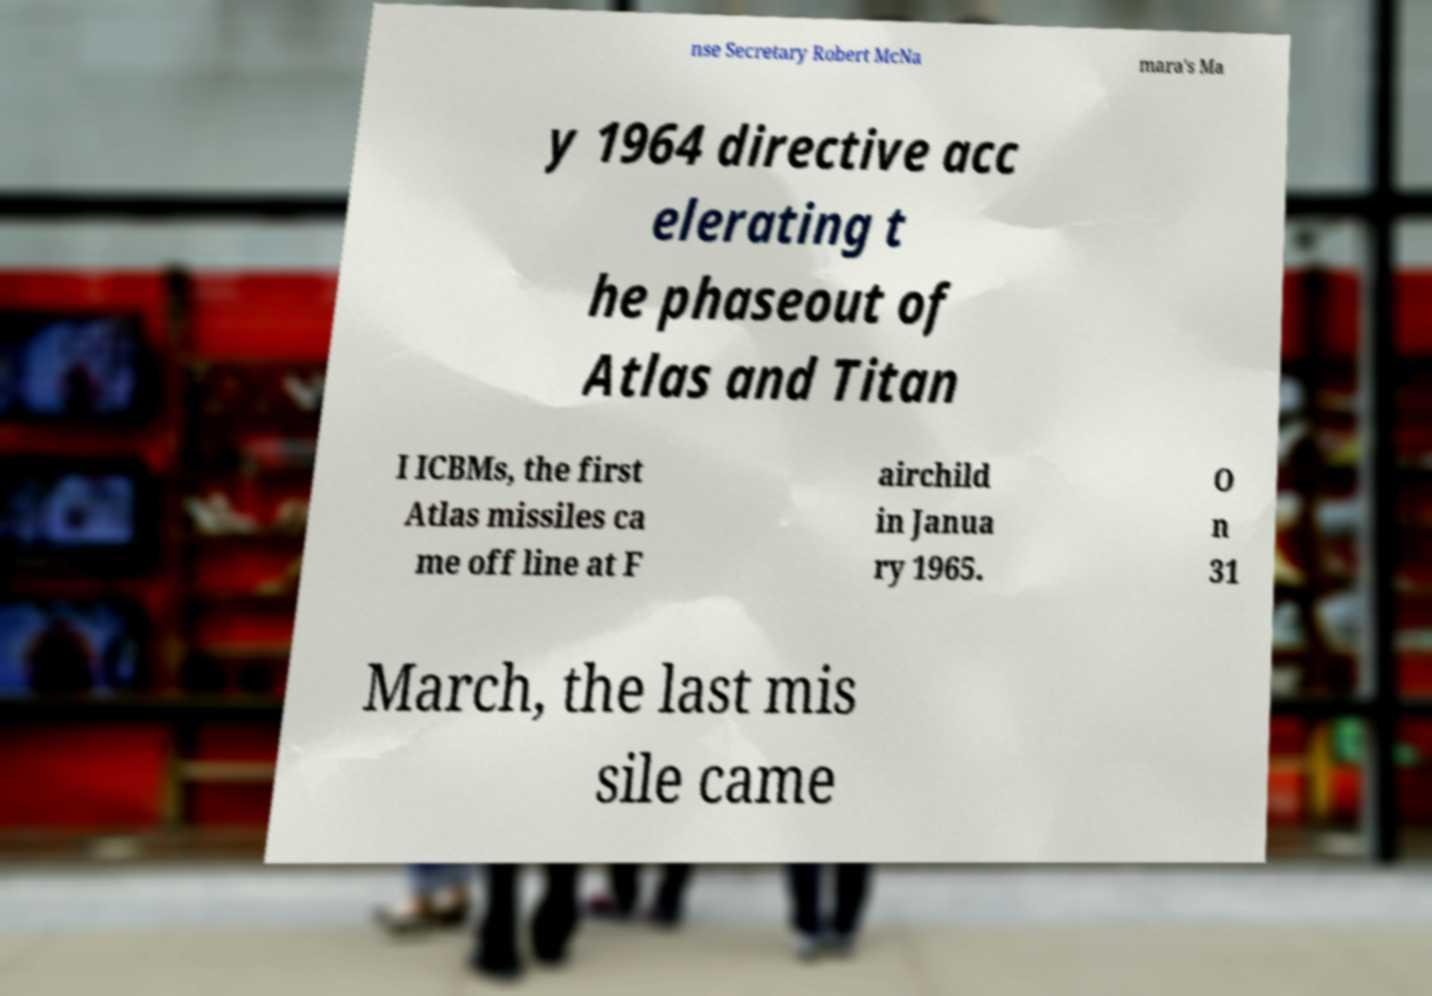There's text embedded in this image that I need extracted. Can you transcribe it verbatim? nse Secretary Robert McNa mara's Ma y 1964 directive acc elerating t he phaseout of Atlas and Titan I ICBMs, the first Atlas missiles ca me off line at F airchild in Janua ry 1965. O n 31 March, the last mis sile came 